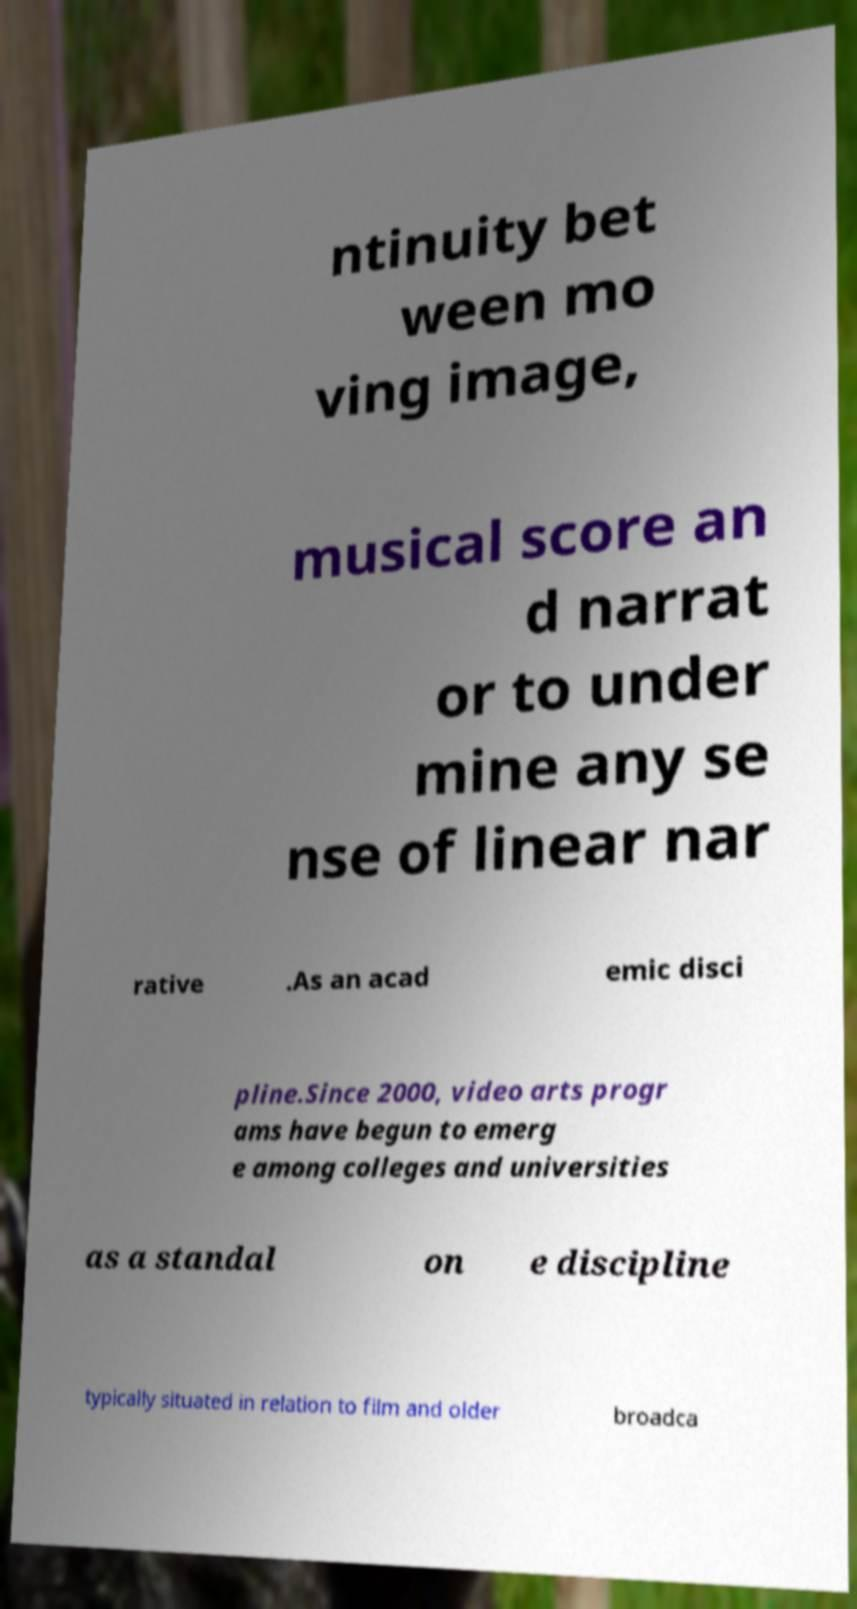There's text embedded in this image that I need extracted. Can you transcribe it verbatim? ntinuity bet ween mo ving image, musical score an d narrat or to under mine any se nse of linear nar rative .As an acad emic disci pline.Since 2000, video arts progr ams have begun to emerg e among colleges and universities as a standal on e discipline typically situated in relation to film and older broadca 